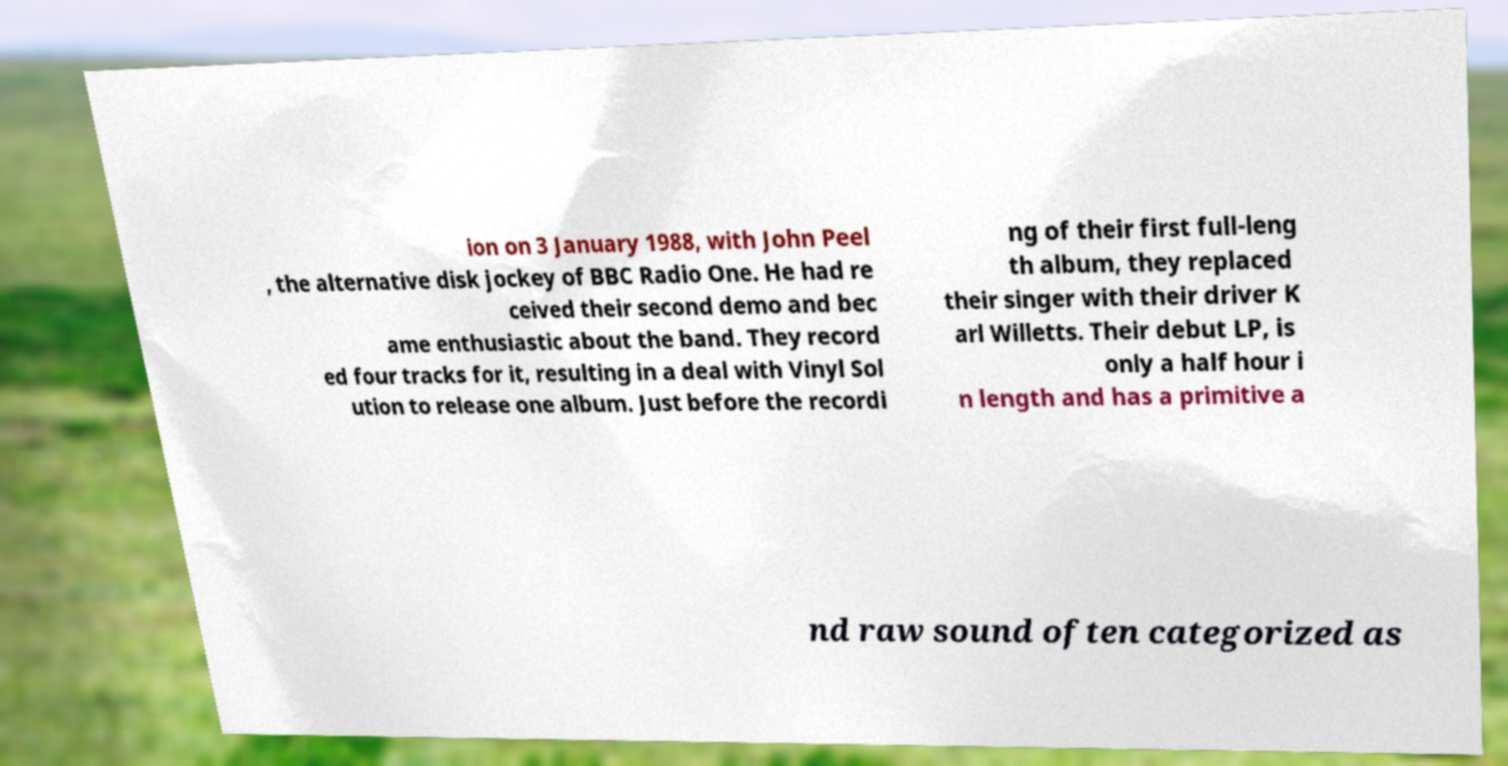For documentation purposes, I need the text within this image transcribed. Could you provide that? ion on 3 January 1988, with John Peel , the alternative disk jockey of BBC Radio One. He had re ceived their second demo and bec ame enthusiastic about the band. They record ed four tracks for it, resulting in a deal with Vinyl Sol ution to release one album. Just before the recordi ng of their first full-leng th album, they replaced their singer with their driver K arl Willetts. Their debut LP, is only a half hour i n length and has a primitive a nd raw sound often categorized as 